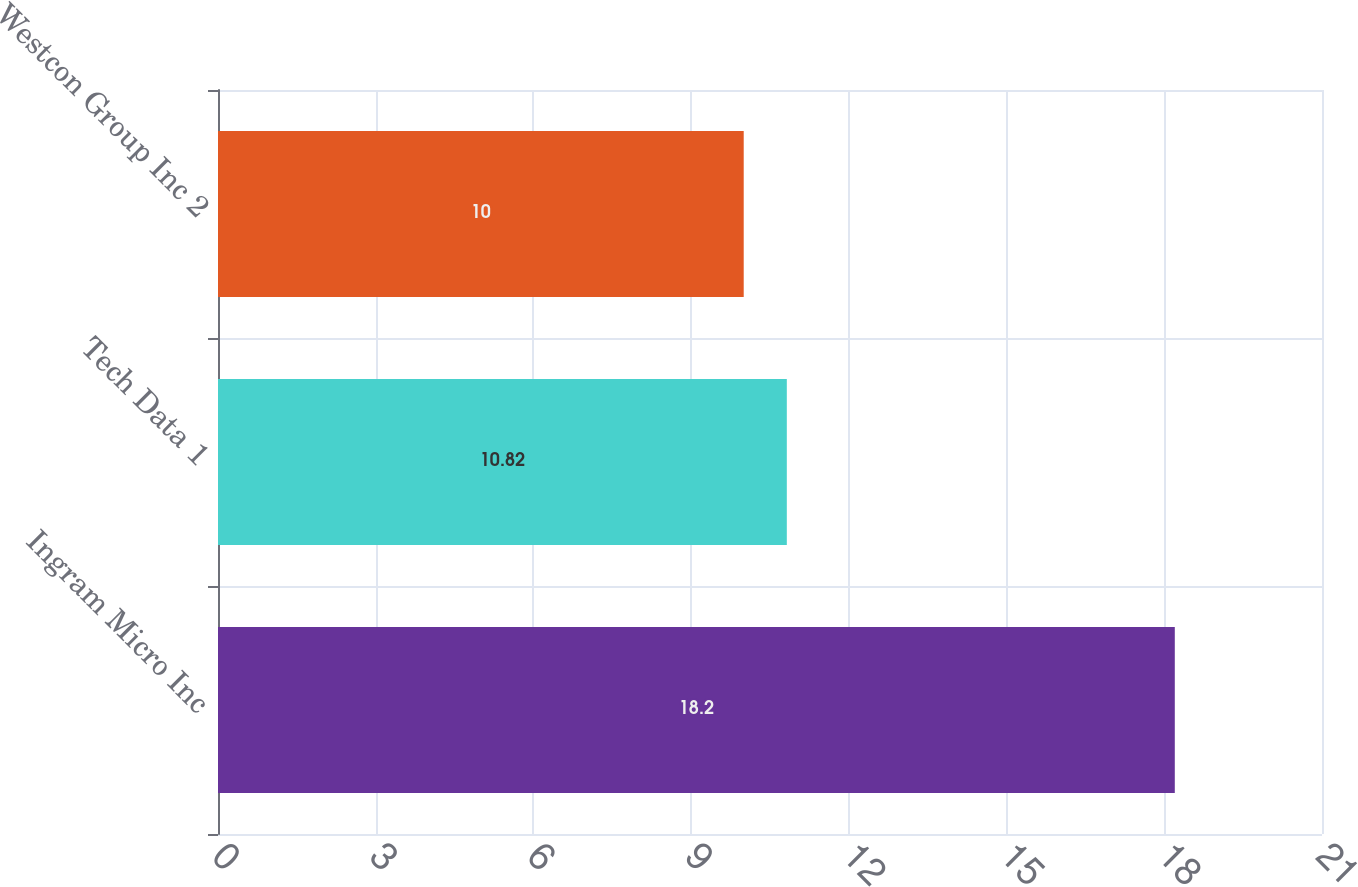Convert chart. <chart><loc_0><loc_0><loc_500><loc_500><bar_chart><fcel>Ingram Micro Inc<fcel>Tech Data 1<fcel>Westcon Group Inc 2<nl><fcel>18.2<fcel>10.82<fcel>10<nl></chart> 